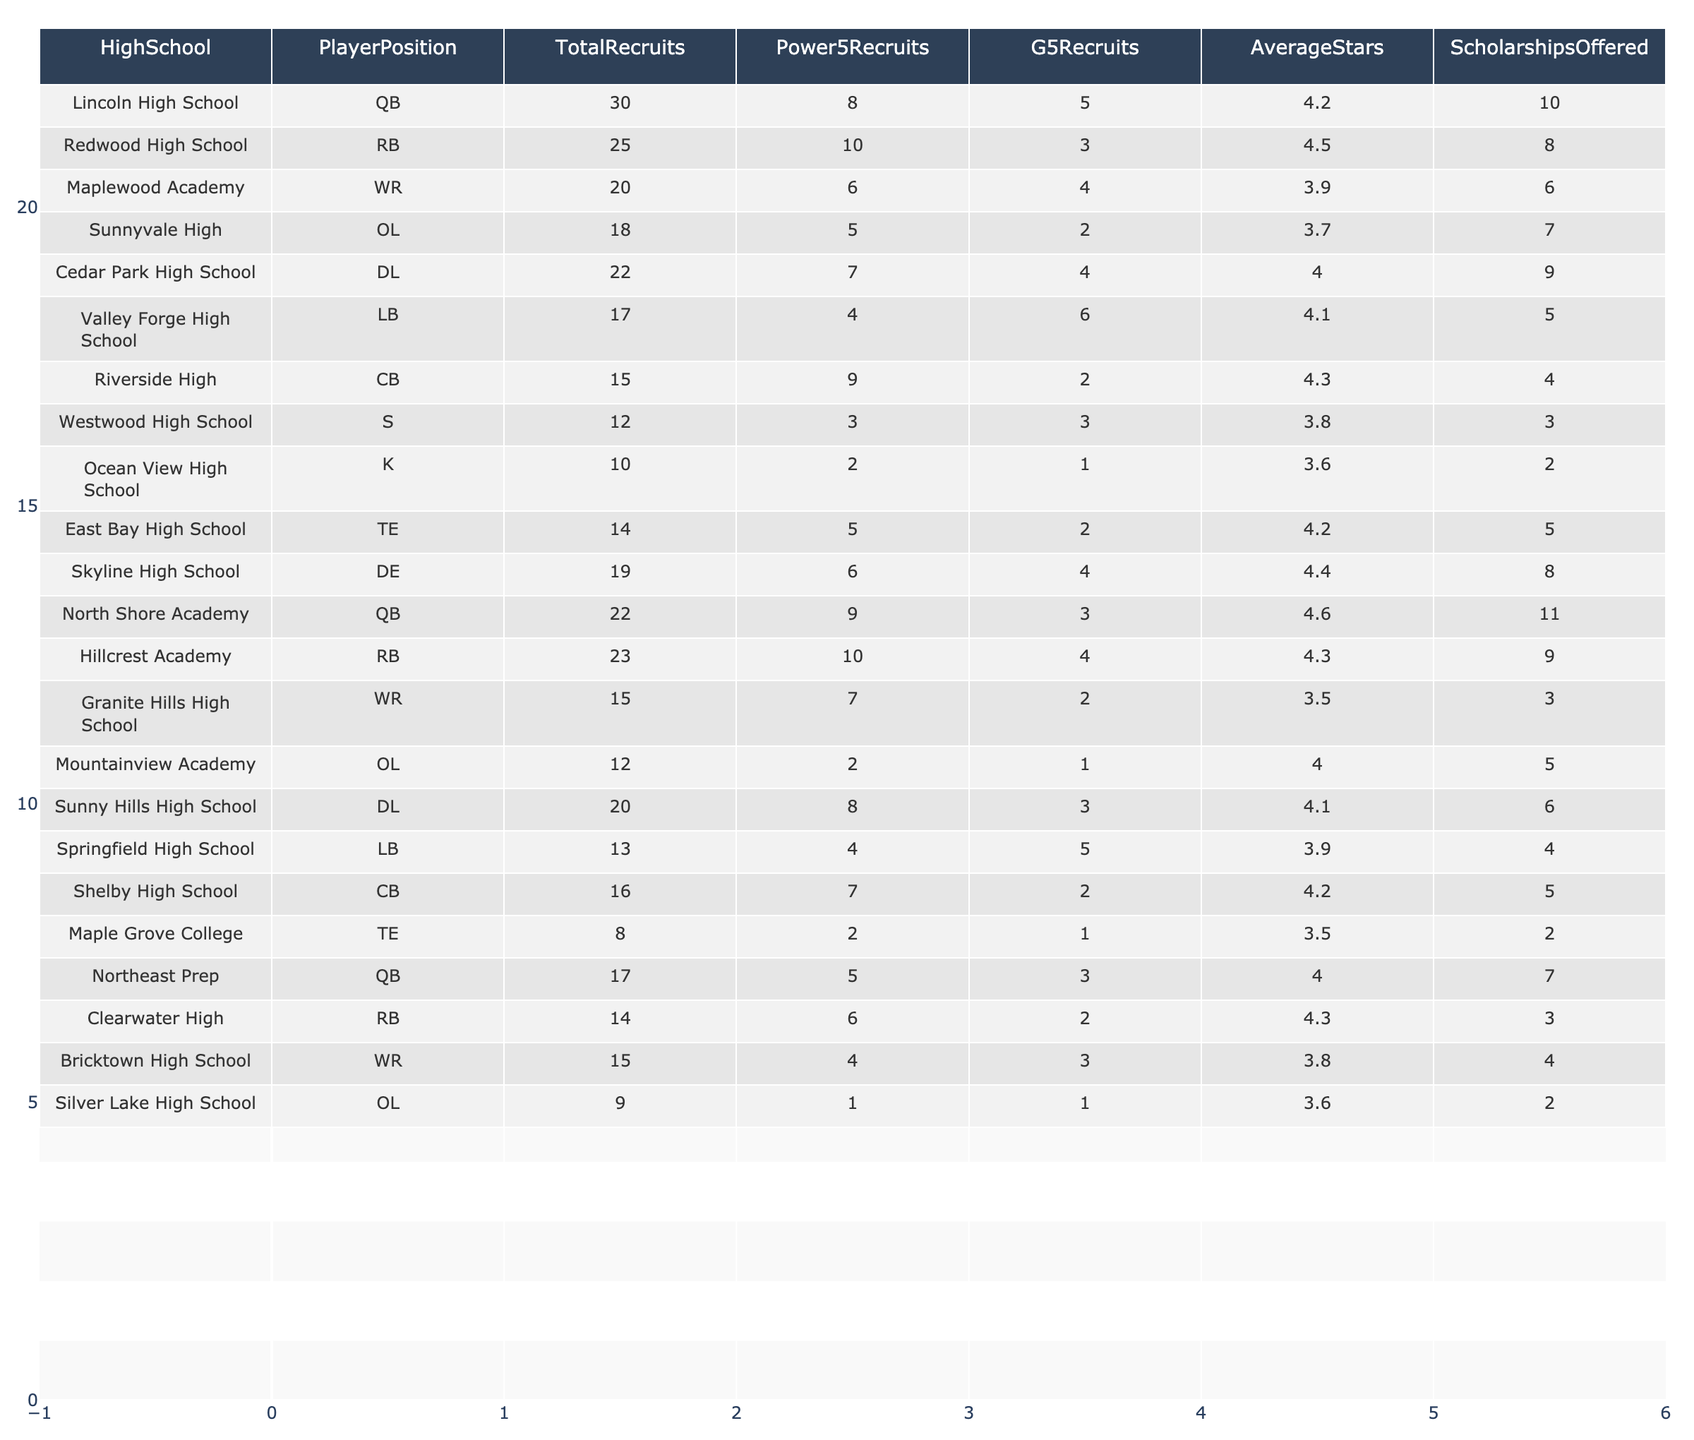What is the total number of recruits from Redwood High School? The table lists the total recruits for Redwood High School as 25.
Answer: 25 Which high school has the highest number of Power 5 recruits? Comparing the "Power5Recruits" column, Lincoln High School has 8, Redwood High School has 10, North Shore Academy has 9, and Hillcrest Academy also has 10 recruits. The highest number is 10, from Redwood High School and Hillcrest Academy.
Answer: 10 What is the average number of scholarships offered by high schools with at least 20 recruits? The schools with at least 20 recruits are Lincoln High School (10), Redwood High School (8), North Shore Academy (11), Hillcrest Academy (9), Sunny Hills High School (6), Cedar Park High School (9), and Ocean View High School (2). The total scholarships offered are 10 + 8 + 11 + 9 + 6 + 9 + 2 = 55. There are 7 data points: 55 / 7 = 7.86.
Answer: 7.86 Are there more G5 recruits from Maplewood Academy or from Shelby High School? Maplewood Academy has 4 G5 recruits, while Shelby High School has 2 G5 recruits. There are more G5 recruits from Maplewood Academy.
Answer: Yes What is the difference between the average stars of recruits from Lincoln High School and Cedar Park High School? Lincoln High School has an average star rating of 4.2, whereas Cedar Park High School has an average of 4.0. The difference is 4.2 - 4.0 = 0.2.
Answer: 0.2 Which player position has the least total recruits and how many? Looking at the "TotalRecruits" column, the S position has 12 total recruits, which is less than any other position listed.
Answer: 12 What is the average number of total recruits for schools categorized under OL? The OL positions are from Sunnyvale High (18), Mountainview Academy (12), and Silver Lake High School (9). The total recruits from these schools is 18 + 12 + 9 = 39. There are 3 data points, so 39 / 3 = 13.
Answer: 13 Is there a high school with more than 5 average stars and at least 10 total recruits? Yes, Redwood High School has an average star rating of 4.5 and a total of 25 recruits.
Answer: Yes What are the average number of scholarships offered to schools with QB as a player position? The schools that have QB positions are Lincoln High School (10), North Shore Academy (11), and Northeast Prep (7). The total number of scholarships offered is 10 + 11 + 7 = 28. The average is 28 / 3 = 9.33.
Answer: 9.33 Which high school has a lower average star rating, Ocean View High School or Maple Grove College? Ocean View High School has an average star rating of 3.6, while Maple Grove College has an average of 3.5. Thus, Maple Grove College has the lower average star rating.
Answer: Yes 